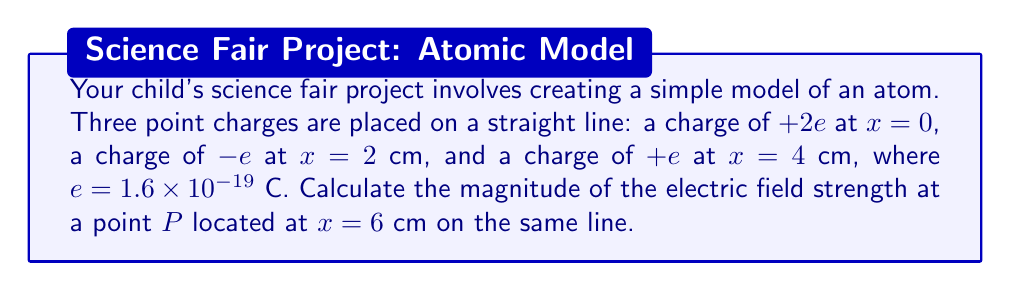Show me your answer to this math problem. Let's approach this step-by-step:

1) The electric field strength due to a point charge is given by:

   $$E = k\frac{q}{r^2}$$

   where $k = 9 \times 10^9$ N⋅m²/C² is Coulomb's constant, $q$ is the charge, and $r$ is the distance from the charge.

2) We need to calculate the electric field from each charge and then add them vectorially. Since all charges are on a line, we can simply add or subtract the magnitudes based on direction.

3) For the charge at $x=0$:
   $q_1 = +2e = 3.2 \times 10^{-19}$ C
   $r_1 = 6$ cm $= 0.06$ m
   $$E_1 = (9 \times 10^9) \frac{3.2 \times 10^{-19}}{(0.06)^2} = 80 \text{ N/C}$$ (to the right)

4) For the charge at $x=2$ cm:
   $q_2 = -e = -1.6 \times 10^{-19}$ C
   $r_2 = 4$ cm $= 0.04$ m
   $$E_2 = (9 \times 10^9) \frac{1.6 \times 10^{-19}}{(0.04)^2} = 90 \text{ N/C}$$ (to the left)

5) For the charge at $x=4$ cm:
   $q_3 = +e = 1.6 \times 10^{-19}$ C
   $r_3 = 2$ cm $= 0.02$ m
   $$E_3 = (9 \times 10^9) \frac{1.6 \times 10^{-19}}{(0.02)^2} = 360 \text{ N/C}$$ (to the right)

6) The net electric field is:
   $$E_{net} = E_1 - E_2 + E_3 = 80 - 90 + 360 = 350 \text{ N/C}$$

7) The magnitude of the electric field strength is 350 N/C, directed to the right.
Answer: 350 N/C 